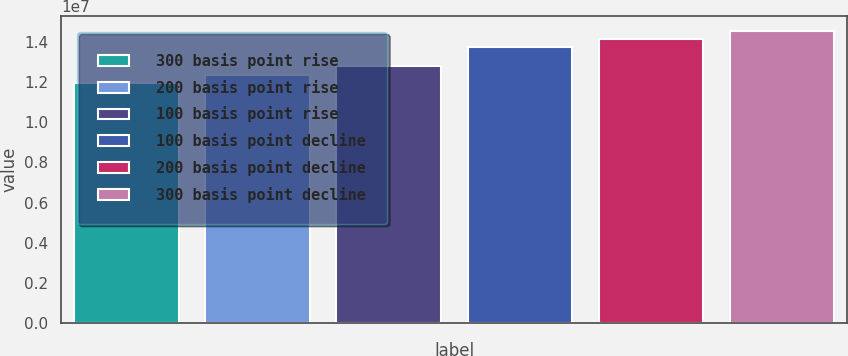<chart> <loc_0><loc_0><loc_500><loc_500><bar_chart><fcel>300 basis point rise<fcel>200 basis point rise<fcel>100 basis point rise<fcel>100 basis point decline<fcel>200 basis point decline<fcel>300 basis point decline<nl><fcel>1.19277e+07<fcel>1.23586e+07<fcel>1.28096e+07<fcel>1.37411e+07<fcel>1.41543e+07<fcel>1.4537e+07<nl></chart> 